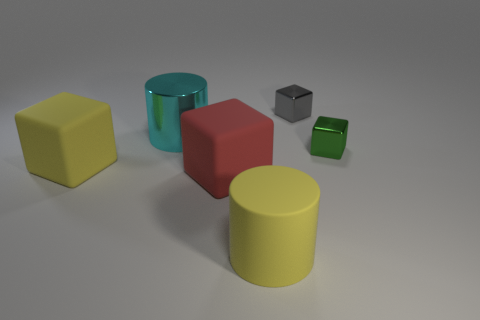The large metal cylinder has what color? The large metal cylinder in the image is grey, exhibiting a metallic sheen typical of unpainted metal surfaces. 